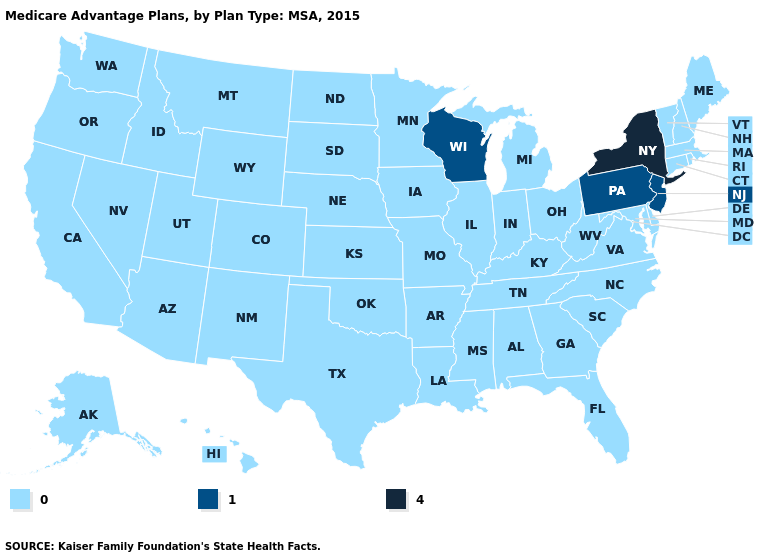What is the value of New York?
Give a very brief answer. 4. What is the highest value in states that border Alabama?
Write a very short answer. 0. What is the value of Nebraska?
Give a very brief answer. 0. Does Indiana have the highest value in the MidWest?
Quick response, please. No. What is the highest value in the USA?
Write a very short answer. 4. Name the states that have a value in the range 1?
Be succinct. New Jersey, Pennsylvania, Wisconsin. What is the value of California?
Keep it brief. 0. Does Wisconsin have the highest value in the MidWest?
Answer briefly. Yes. Name the states that have a value in the range 0?
Keep it brief. Alaska, Alabama, Arkansas, Arizona, California, Colorado, Connecticut, Delaware, Florida, Georgia, Hawaii, Iowa, Idaho, Illinois, Indiana, Kansas, Kentucky, Louisiana, Massachusetts, Maryland, Maine, Michigan, Minnesota, Missouri, Mississippi, Montana, North Carolina, North Dakota, Nebraska, New Hampshire, New Mexico, Nevada, Ohio, Oklahoma, Oregon, Rhode Island, South Carolina, South Dakota, Tennessee, Texas, Utah, Virginia, Vermont, Washington, West Virginia, Wyoming. Name the states that have a value in the range 0?
Keep it brief. Alaska, Alabama, Arkansas, Arizona, California, Colorado, Connecticut, Delaware, Florida, Georgia, Hawaii, Iowa, Idaho, Illinois, Indiana, Kansas, Kentucky, Louisiana, Massachusetts, Maryland, Maine, Michigan, Minnesota, Missouri, Mississippi, Montana, North Carolina, North Dakota, Nebraska, New Hampshire, New Mexico, Nevada, Ohio, Oklahoma, Oregon, Rhode Island, South Carolina, South Dakota, Tennessee, Texas, Utah, Virginia, Vermont, Washington, West Virginia, Wyoming. What is the value of Delaware?
Short answer required. 0. What is the value of California?
Concise answer only. 0. What is the value of North Carolina?
Give a very brief answer. 0. 